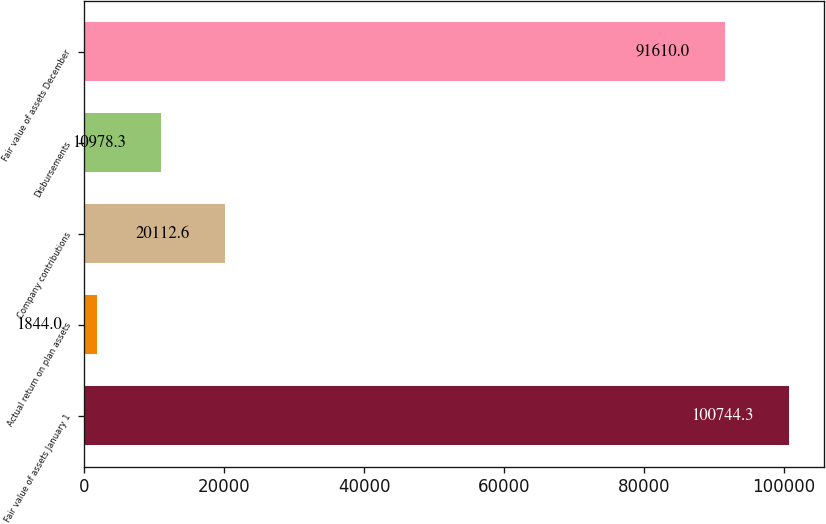<chart> <loc_0><loc_0><loc_500><loc_500><bar_chart><fcel>Fair value of assets January 1<fcel>Actual return on plan assets<fcel>Company contributions<fcel>Disbursements<fcel>Fair value of assets December<nl><fcel>100744<fcel>1844<fcel>20112.6<fcel>10978.3<fcel>91610<nl></chart> 